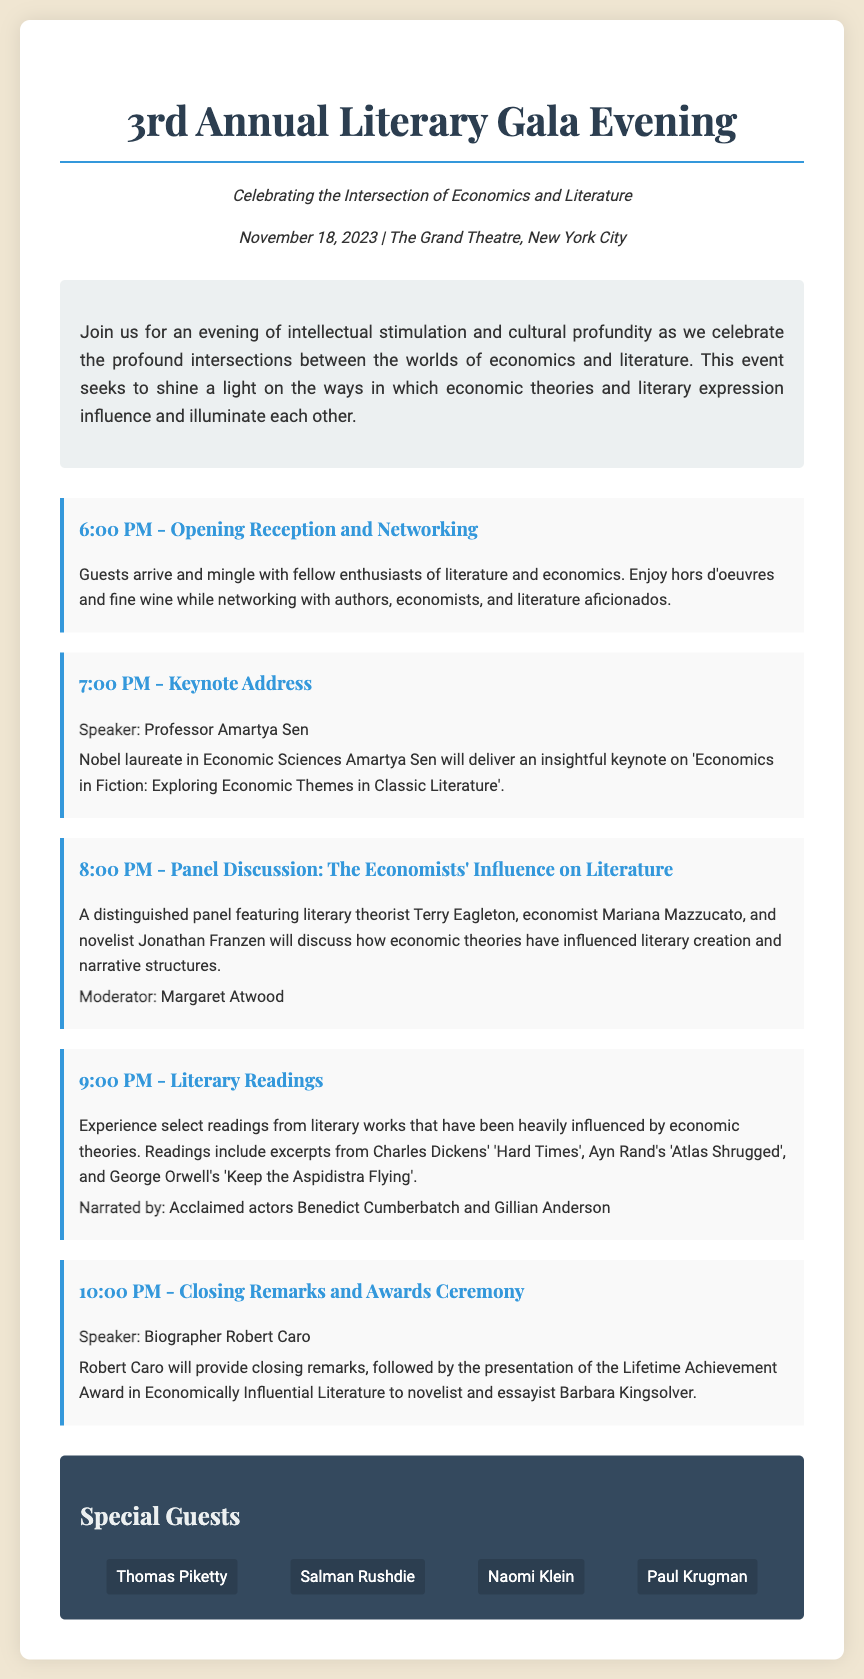What is the title of the event? The title of the event is stated prominently at the top of the document, highlighting the occasion.
Answer: 3rd Annual Literary Gala Evening When is the event scheduled? The date of the event is provided in the event-info section of the document.
Answer: November 18, 2023 Who is delivering the keynote address? The keynote speaker is listed in the schedule under the keynote address section.
Answer: Professor Amartya Sen What will happen at 9:00 PM? The time and activity scheduled at 9:00 PM are mentioned in the schedule section.
Answer: Literary Readings Who will provide the closing remarks? The speaker for the closing remarks is identified in the schedule for the last segment.
Answer: Robert Caro Which literary work is mentioned first in the literary readings? The first literary work referenced in the schedule under literary readings is identified.
Answer: Charles Dickens' 'Hard Times' What is the name of the moderator for the panel discussion? The moderator for the panel is specified in the panel discussion section of the schedule.
Answer: Margaret Atwood List one of the special guests attending the event. The special guests are listed in the special guests section of the document.
Answer: Thomas Piketty 